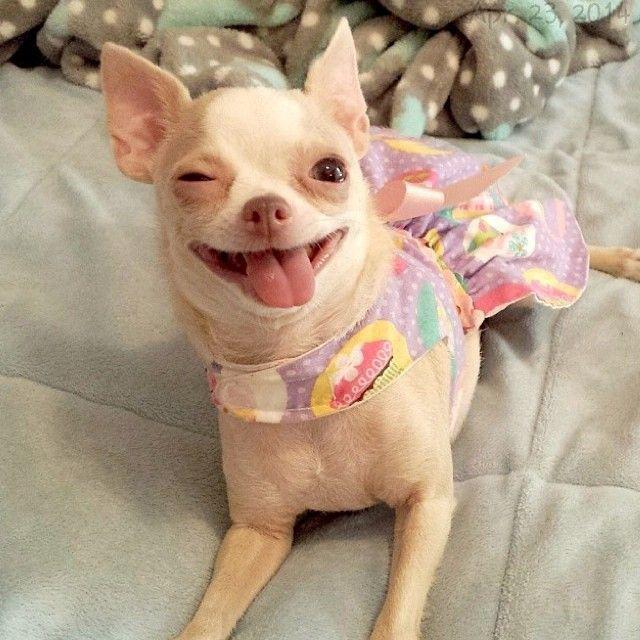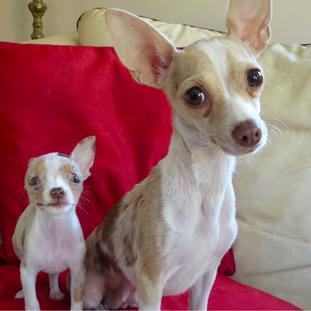The first image is the image on the left, the second image is the image on the right. Analyze the images presented: Is the assertion "At least one dog is wearing a bowtie." valid? Answer yes or no. No. The first image is the image on the left, the second image is the image on the right. Evaluate the accuracy of this statement regarding the images: "There are 3 dogs in the image pair". Is it true? Answer yes or no. Yes. 